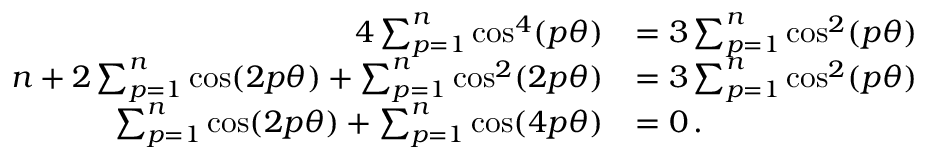<formula> <loc_0><loc_0><loc_500><loc_500>\begin{array} { r l } { 4 \sum _ { p = 1 } ^ { n } \cos ^ { 4 } ( p \theta ) } & { = 3 \sum _ { p = 1 } ^ { n } \cos ^ { 2 } ( p \theta ) } \\ { n + 2 \sum _ { p = 1 } ^ { n } \cos ( 2 p \theta ) + \sum _ { p = 1 } ^ { n } \cos ^ { 2 } ( 2 p \theta ) } & { = 3 \sum _ { p = 1 } ^ { n } \cos ^ { 2 } ( p \theta ) \, } \\ { \sum _ { p = 1 } ^ { n } \cos ( 2 p \theta ) + \sum _ { p = 1 } ^ { n } \cos ( 4 p \theta ) } & { = 0 \, . } \end{array}</formula> 